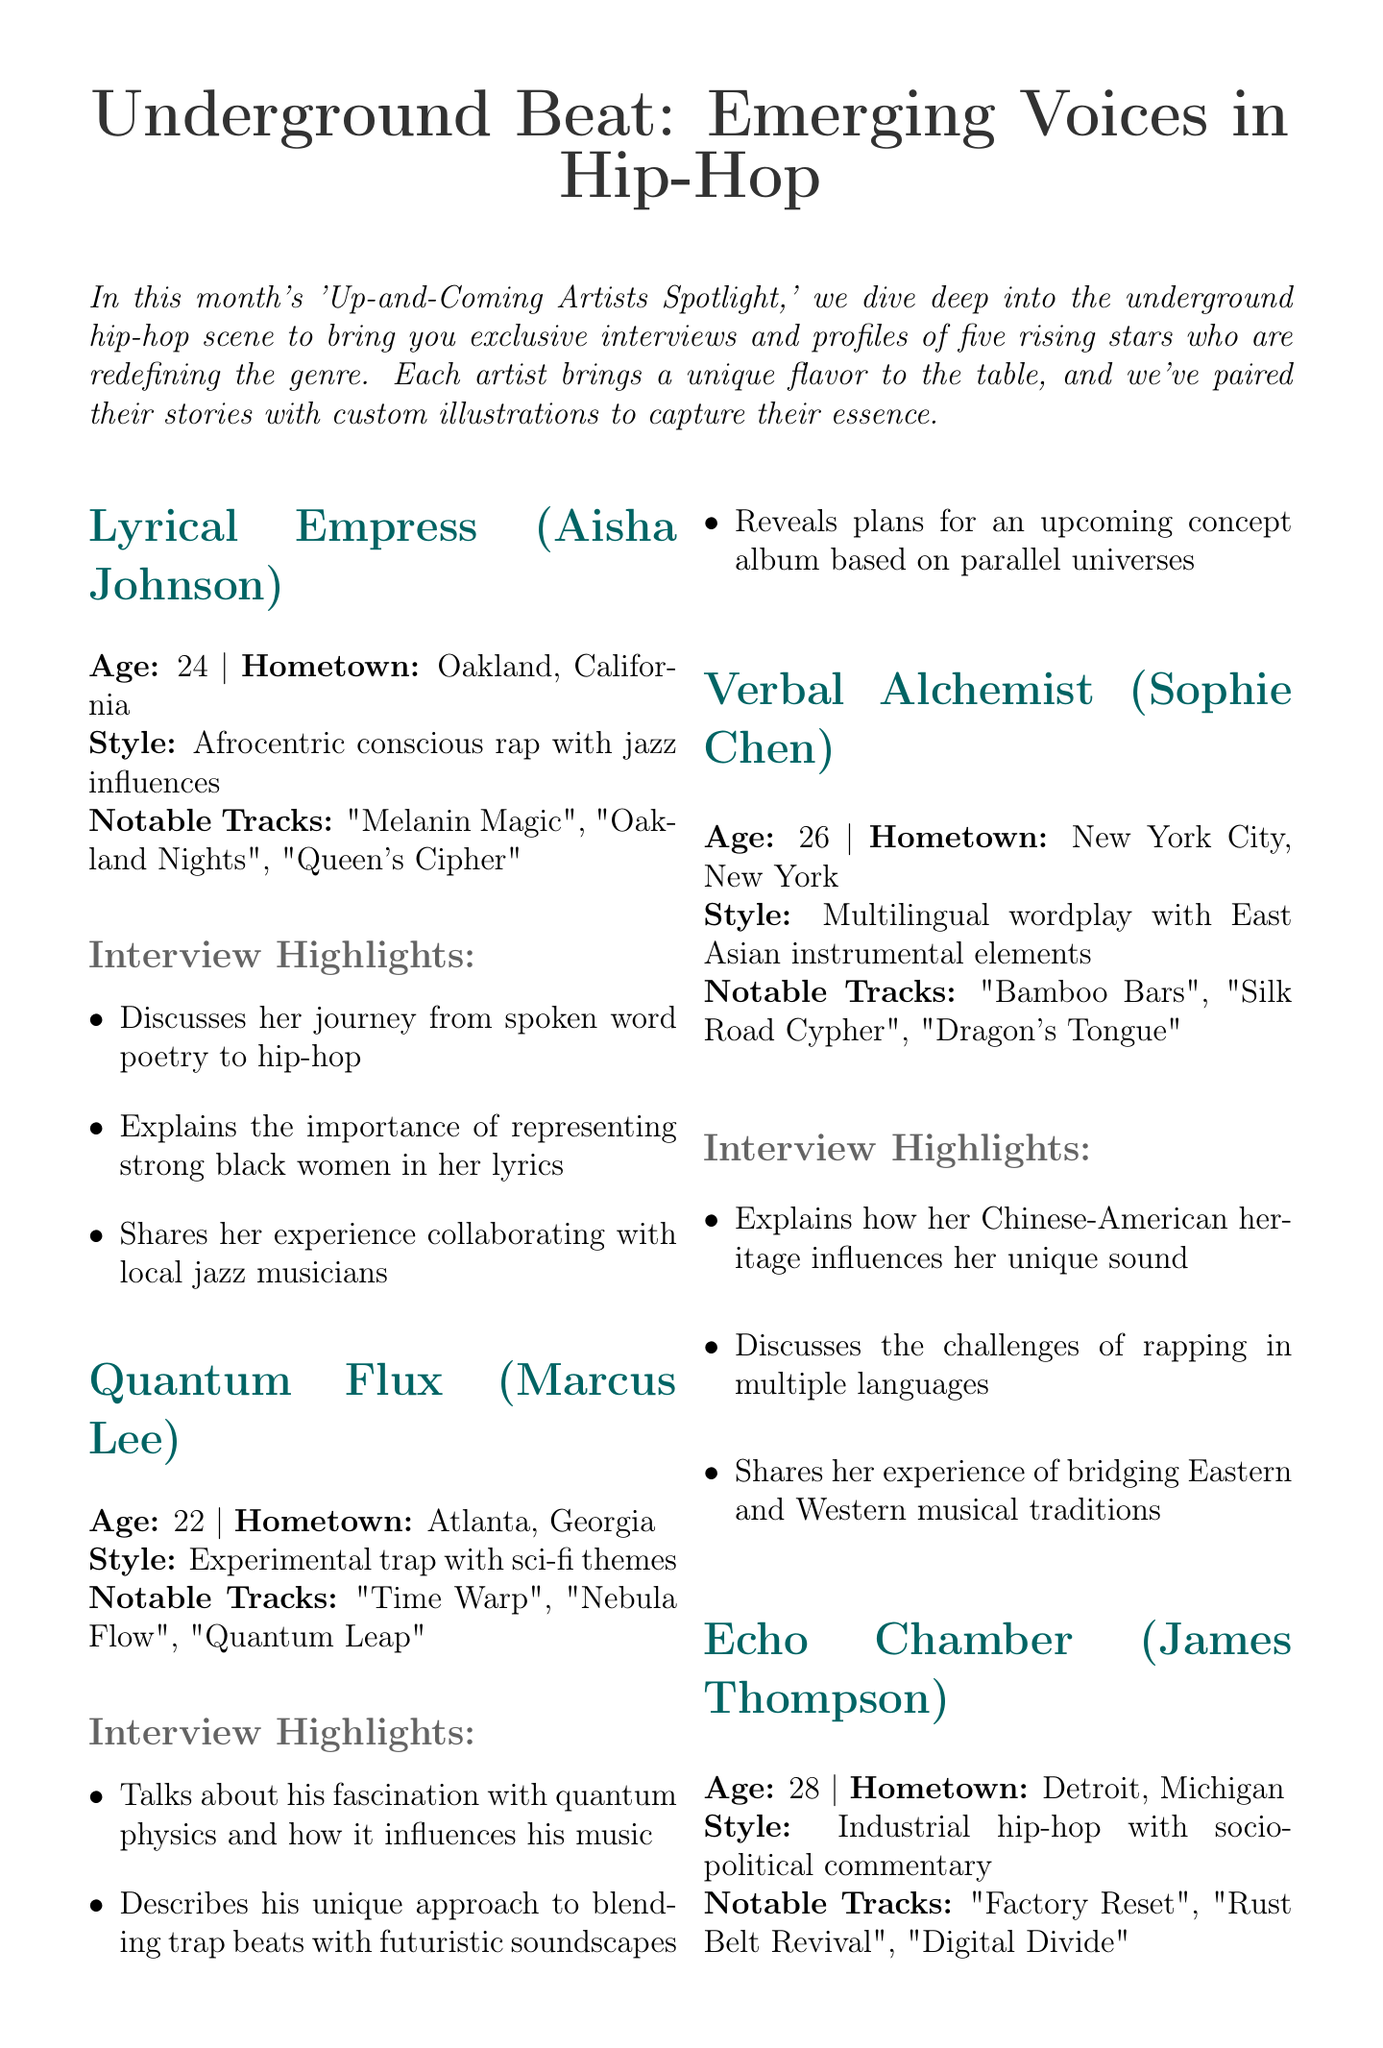What is the title of the newsletter? The title is prominently displayed at the beginning of the newsletter.
Answer: Underground Beat: Emerging Voices in Hip-Hop How many artists are featured in this spotlight? The document explicitly states the number of rising stars highlighted in the newsletter.
Answer: Five What is Lyrical Empress's real name? The real name is provided alongside the artist's stage name.
Answer: Aisha Johnson Which city is Quantum Flux from? The newsletter includes the hometown of each artist.
Answer: Atlanta, Georgia What is the signature style of Echo Chamber? Each artist's signature style is described in a specific section.
Answer: Industrial hip-hop with socio-political commentary How old is Solar Flare? The age of each featured artist is mentioned in their profile.
Answer: 23 What themes influence Solar Flare's lyrics? The document highlights the themes associated with each artist, particularly for Solar Flare.
Answer: Environmental themes How does Verbal Alchemist's heritage influence her music? The document notes Verbal Alchemist's heritage as a significant influence on her sound.
Answer: Chinese-American What type of illustration accompanies each artist's profile? The newsletter describes the illustrations paired with each artist, reflecting their unique styles.
Answer: Custom illustrations 